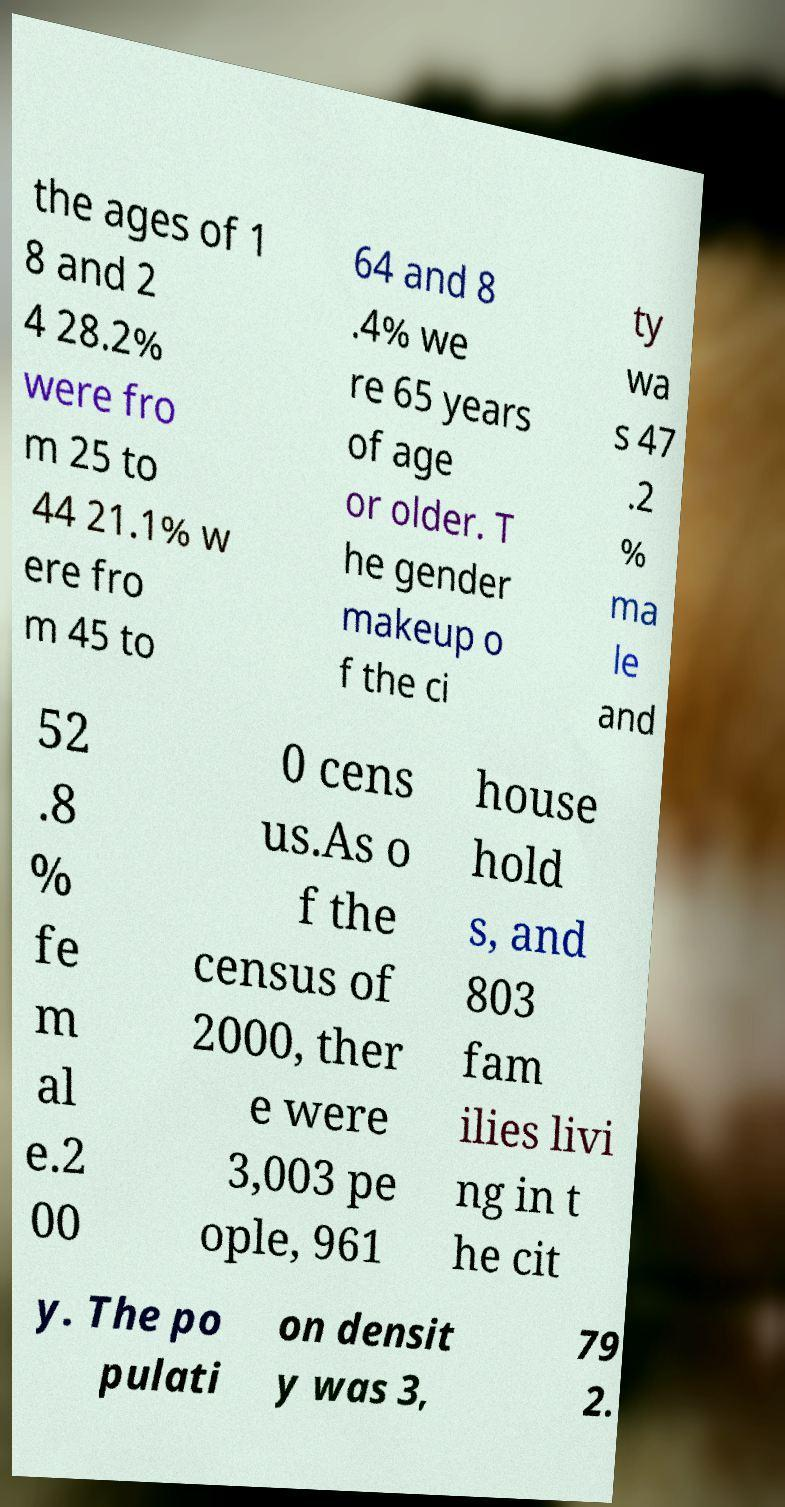Please identify and transcribe the text found in this image. the ages of 1 8 and 2 4 28.2% were fro m 25 to 44 21.1% w ere fro m 45 to 64 and 8 .4% we re 65 years of age or older. T he gender makeup o f the ci ty wa s 47 .2 % ma le and 52 .8 % fe m al e.2 00 0 cens us.As o f the census of 2000, ther e were 3,003 pe ople, 961 house hold s, and 803 fam ilies livi ng in t he cit y. The po pulati on densit y was 3, 79 2. 